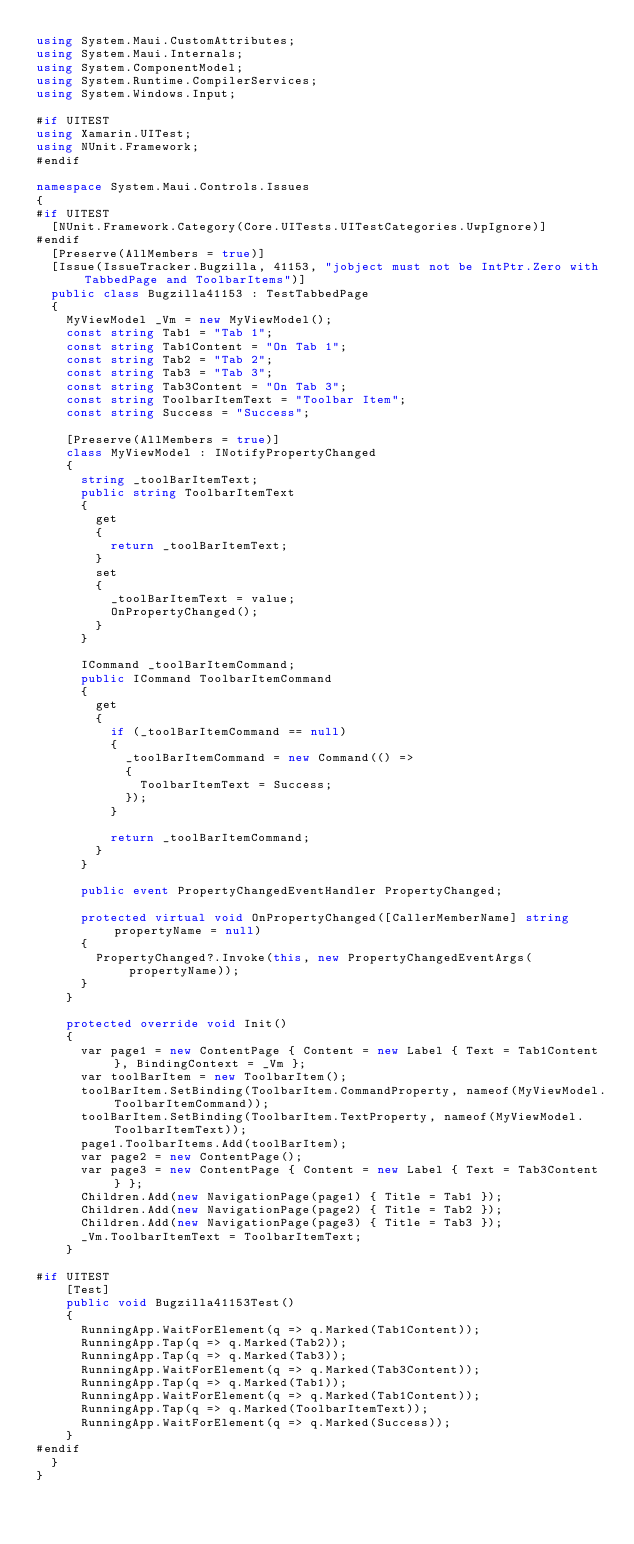<code> <loc_0><loc_0><loc_500><loc_500><_C#_>using System.Maui.CustomAttributes;
using System.Maui.Internals;
using System.ComponentModel;
using System.Runtime.CompilerServices;
using System.Windows.Input;

#if UITEST
using Xamarin.UITest;
using NUnit.Framework;
#endif

namespace System.Maui.Controls.Issues
{
#if UITEST
	[NUnit.Framework.Category(Core.UITests.UITestCategories.UwpIgnore)]
#endif
	[Preserve(AllMembers = true)]
	[Issue(IssueTracker.Bugzilla, 41153, "jobject must not be IntPtr.Zero with TabbedPage and ToolbarItems")]
	public class Bugzilla41153 : TestTabbedPage
	{
		MyViewModel _Vm = new MyViewModel();
		const string Tab1 = "Tab 1";
		const string Tab1Content = "On Tab 1";
		const string Tab2 = "Tab 2";
		const string Tab3 = "Tab 3";
		const string Tab3Content = "On Tab 3";
		const string ToolbarItemText = "Toolbar Item";
		const string Success = "Success";

		[Preserve(AllMembers = true)]
		class MyViewModel : INotifyPropertyChanged
		{
			string _toolBarItemText;
			public string ToolbarItemText
			{
				get
				{
					return _toolBarItemText;
				}
				set
				{
					_toolBarItemText = value;
					OnPropertyChanged();
				}
			}

			ICommand _toolBarItemCommand;
			public ICommand ToolbarItemCommand
			{
				get
				{
					if (_toolBarItemCommand == null)
					{
						_toolBarItemCommand = new Command(() =>
						{
							ToolbarItemText = Success;
						});
					}

					return _toolBarItemCommand;
				}
			}

			public event PropertyChangedEventHandler PropertyChanged;

			protected virtual void OnPropertyChanged([CallerMemberName] string propertyName = null)
			{
				PropertyChanged?.Invoke(this, new PropertyChangedEventArgs(propertyName));
			}
		}

		protected override void Init()
		{
			var page1 = new ContentPage { Content = new Label { Text = Tab1Content }, BindingContext = _Vm };
			var toolBarItem = new ToolbarItem();
			toolBarItem.SetBinding(ToolbarItem.CommandProperty, nameof(MyViewModel.ToolbarItemCommand));
			toolBarItem.SetBinding(ToolbarItem.TextProperty, nameof(MyViewModel.ToolbarItemText));
			page1.ToolbarItems.Add(toolBarItem);
			var page2 = new ContentPage();
			var page3 = new ContentPage { Content = new Label { Text = Tab3Content } };
			Children.Add(new NavigationPage(page1) { Title = Tab1 });
			Children.Add(new NavigationPage(page2) { Title = Tab2 });
			Children.Add(new NavigationPage(page3) { Title = Tab3 });
			_Vm.ToolbarItemText = ToolbarItemText;
		}

#if UITEST
		[Test]
		public void Bugzilla41153Test()
		{
			RunningApp.WaitForElement(q => q.Marked(Tab1Content));
			RunningApp.Tap(q => q.Marked(Tab2));
			RunningApp.Tap(q => q.Marked(Tab3));
			RunningApp.WaitForElement(q => q.Marked(Tab3Content));
			RunningApp.Tap(q => q.Marked(Tab1));
			RunningApp.WaitForElement(q => q.Marked(Tab1Content));
			RunningApp.Tap(q => q.Marked(ToolbarItemText));
			RunningApp.WaitForElement(q => q.Marked(Success));
		}
#endif
	}
}</code> 